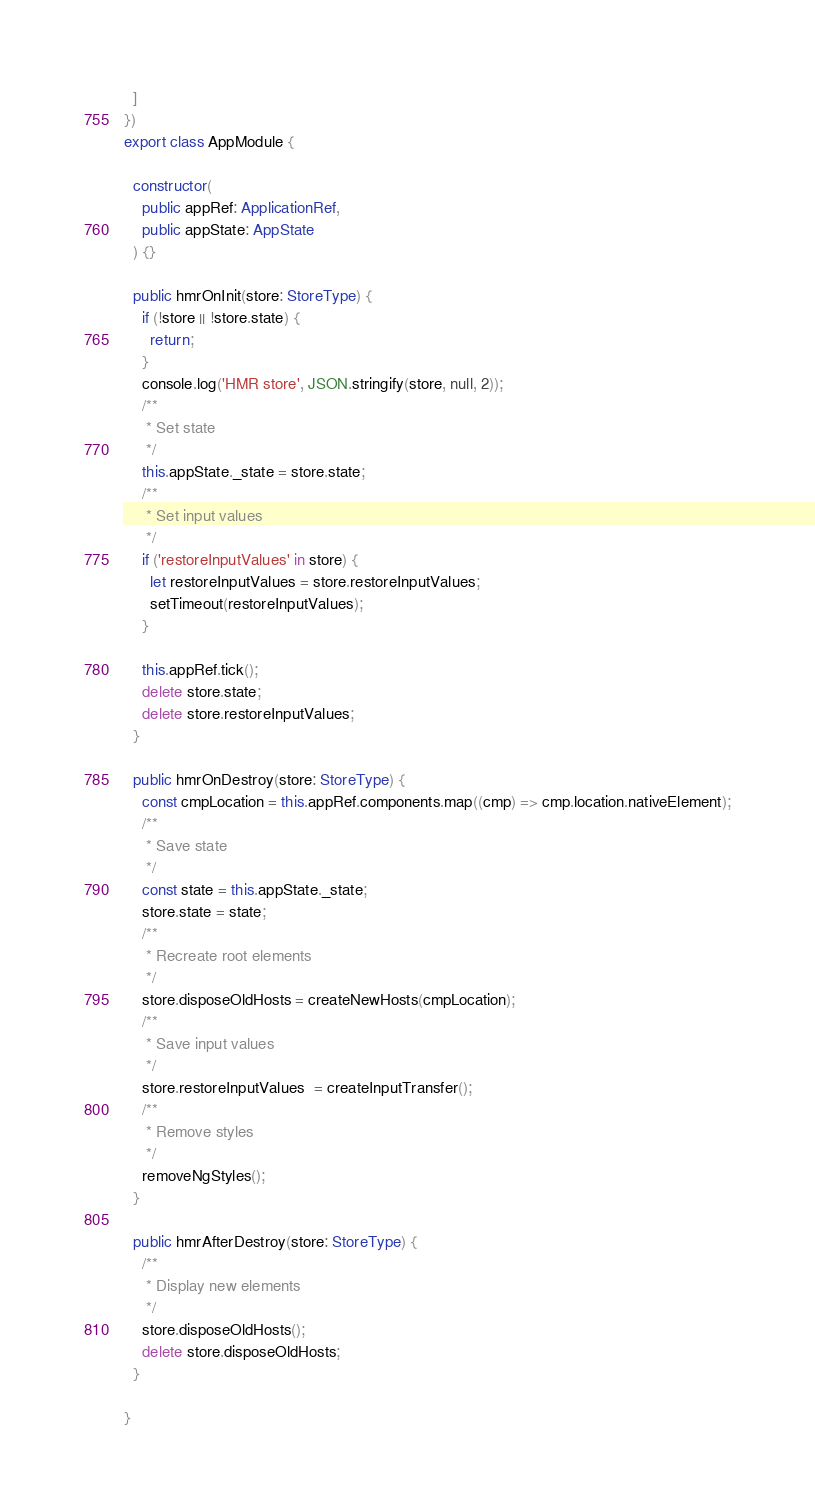<code> <loc_0><loc_0><loc_500><loc_500><_TypeScript_>  ]
})
export class AppModule {

  constructor(
    public appRef: ApplicationRef,
    public appState: AppState
  ) {}

  public hmrOnInit(store: StoreType) {
    if (!store || !store.state) {
      return;
    }
    console.log('HMR store', JSON.stringify(store, null, 2));
    /**
     * Set state
     */
    this.appState._state = store.state;
    /**
     * Set input values
     */
    if ('restoreInputValues' in store) {
      let restoreInputValues = store.restoreInputValues;
      setTimeout(restoreInputValues);
    }

    this.appRef.tick();
    delete store.state;
    delete store.restoreInputValues;
  }

  public hmrOnDestroy(store: StoreType) {
    const cmpLocation = this.appRef.components.map((cmp) => cmp.location.nativeElement);
    /**
     * Save state
     */
    const state = this.appState._state;
    store.state = state;
    /**
     * Recreate root elements
     */
    store.disposeOldHosts = createNewHosts(cmpLocation);
    /**
     * Save input values
     */
    store.restoreInputValues  = createInputTransfer();
    /**
     * Remove styles
     */
    removeNgStyles();
  }

  public hmrAfterDestroy(store: StoreType) {
    /**
     * Display new elements
     */
    store.disposeOldHosts();
    delete store.disposeOldHosts;
  }

}
</code> 